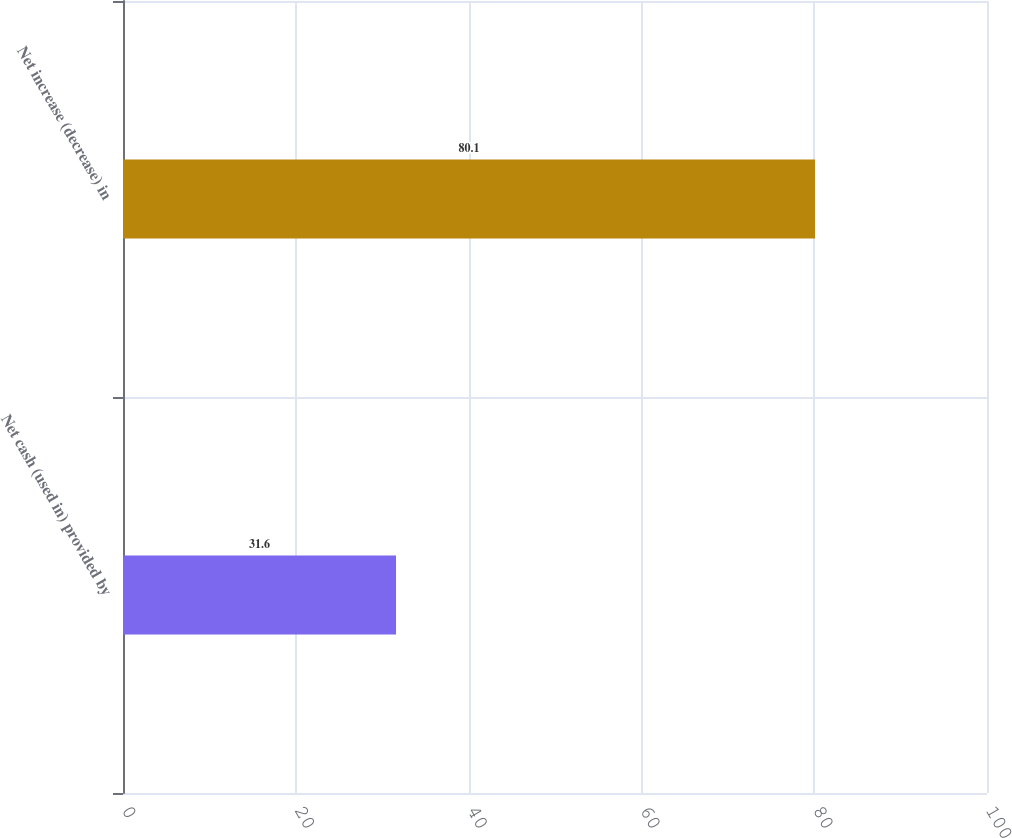<chart> <loc_0><loc_0><loc_500><loc_500><bar_chart><fcel>Net cash (used in) provided by<fcel>Net increase (decrease) in<nl><fcel>31.6<fcel>80.1<nl></chart> 